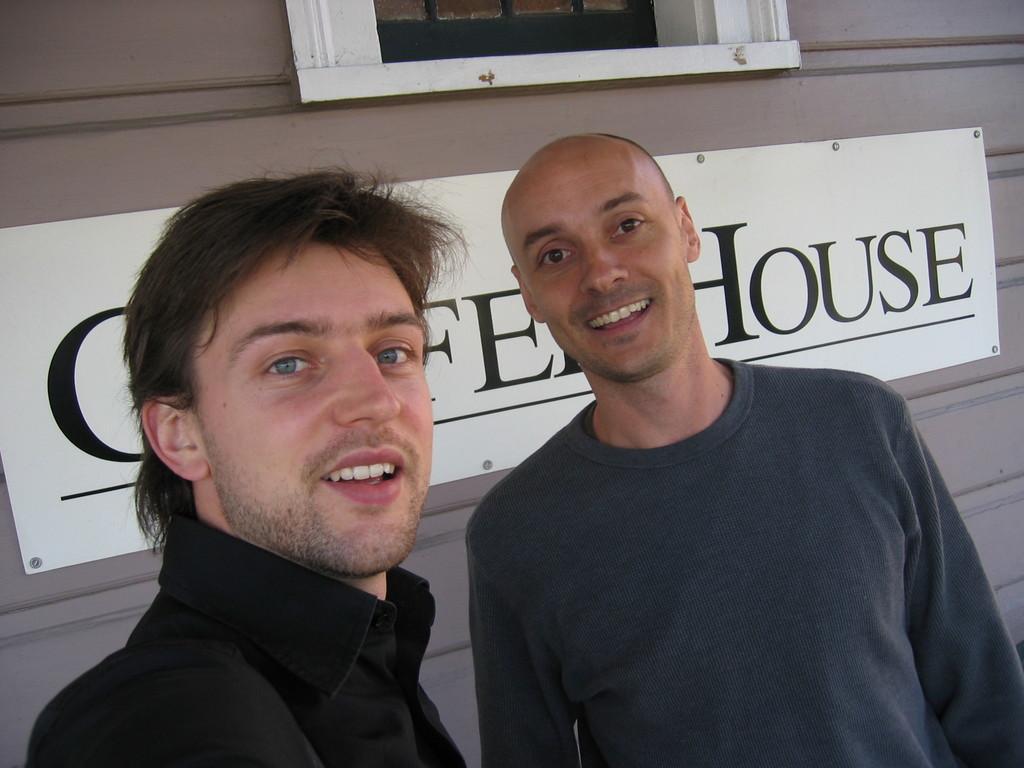Please provide a concise description of this image. There are two men standing and smiling. This looks like a name board, which is fixed to the wall. I think this is a window. 